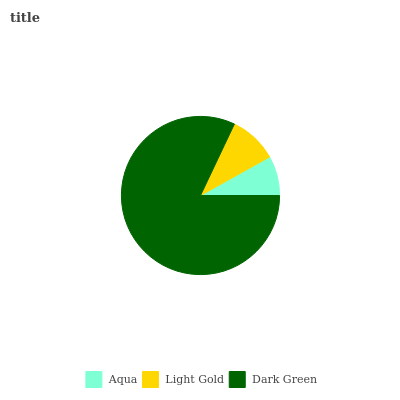Is Aqua the minimum?
Answer yes or no. Yes. Is Dark Green the maximum?
Answer yes or no. Yes. Is Light Gold the minimum?
Answer yes or no. No. Is Light Gold the maximum?
Answer yes or no. No. Is Light Gold greater than Aqua?
Answer yes or no. Yes. Is Aqua less than Light Gold?
Answer yes or no. Yes. Is Aqua greater than Light Gold?
Answer yes or no. No. Is Light Gold less than Aqua?
Answer yes or no. No. Is Light Gold the high median?
Answer yes or no. Yes. Is Light Gold the low median?
Answer yes or no. Yes. Is Dark Green the high median?
Answer yes or no. No. Is Dark Green the low median?
Answer yes or no. No. 